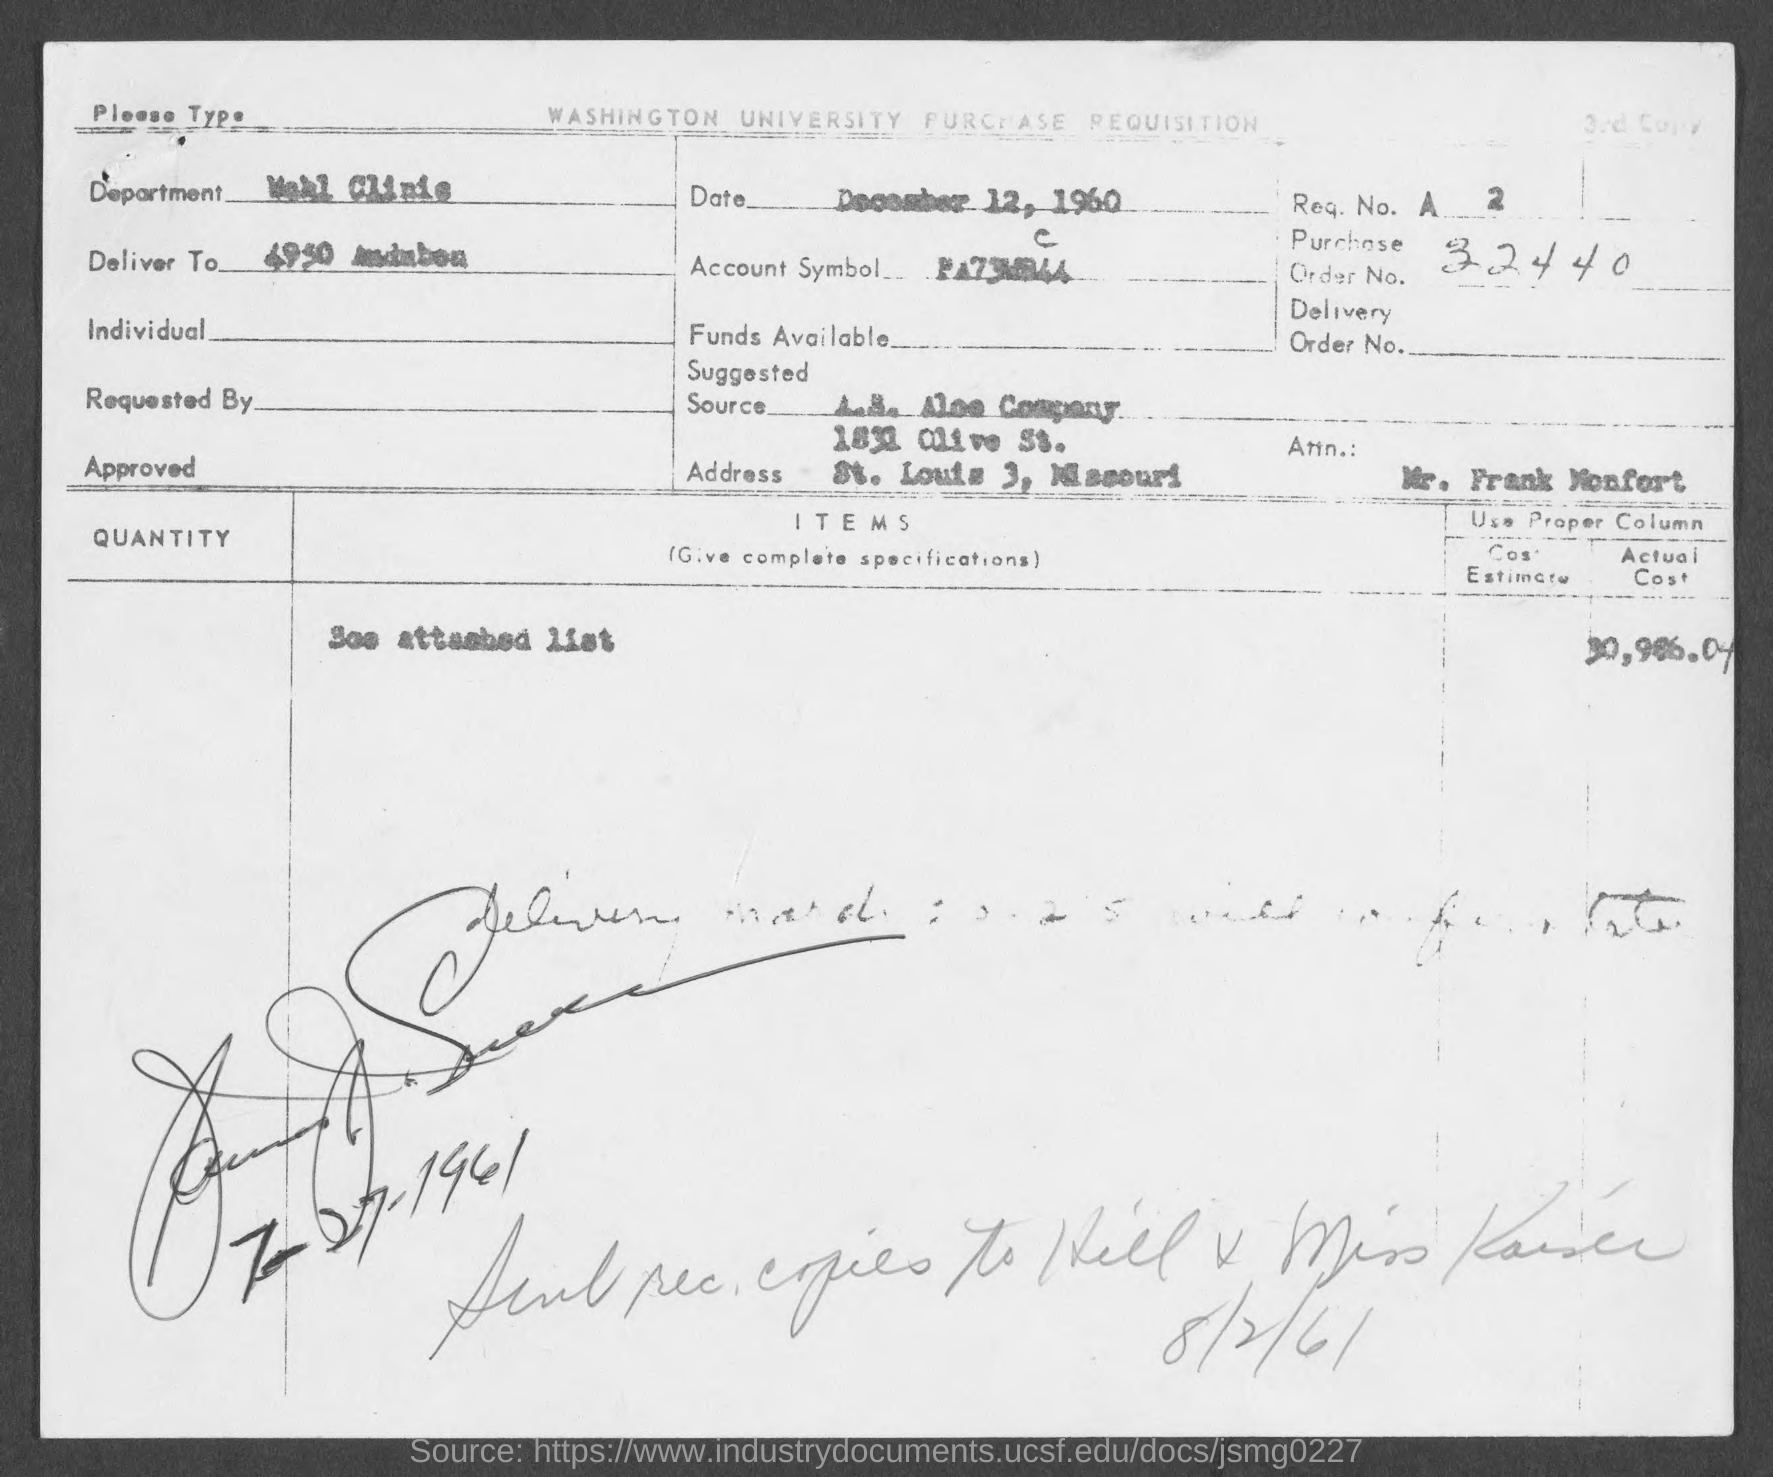Identify some key points in this picture. The date in the form is "December 12, 1960. 